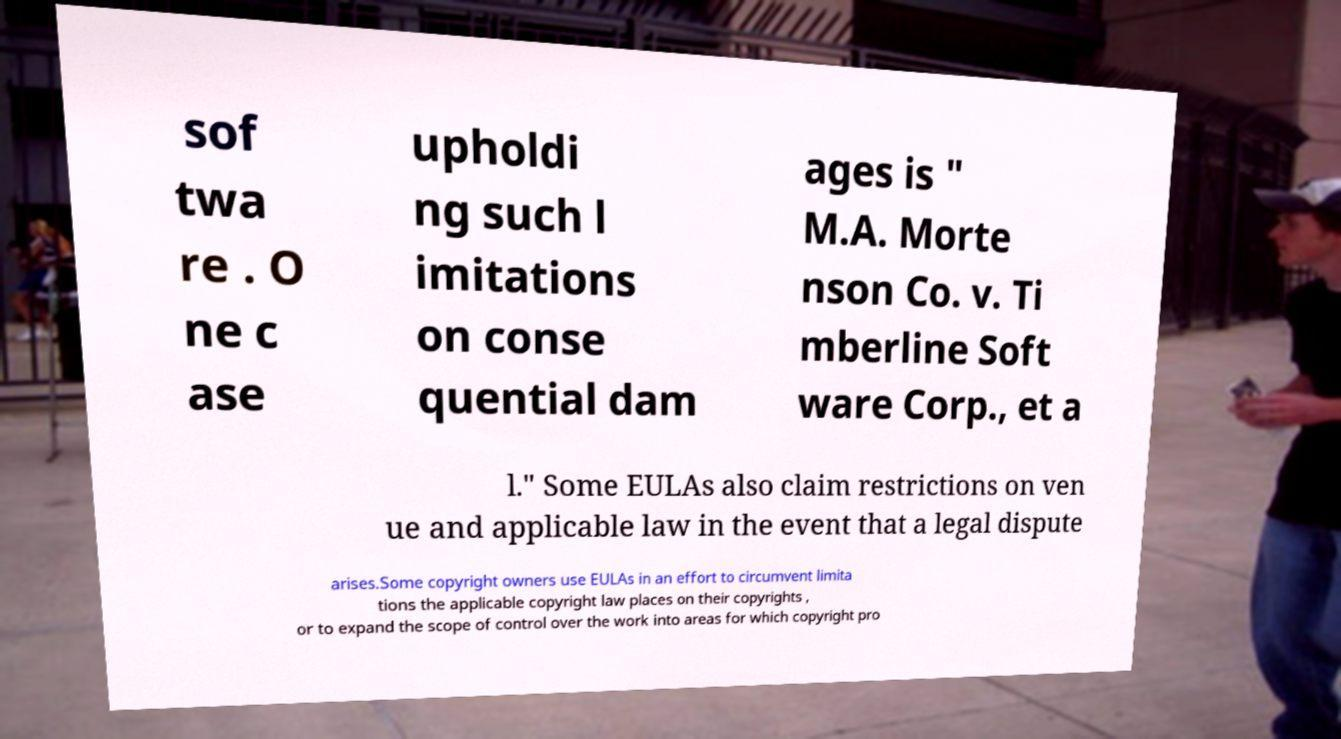Could you extract and type out the text from this image? sof twa re . O ne c ase upholdi ng such l imitations on conse quential dam ages is " M.A. Morte nson Co. v. Ti mberline Soft ware Corp., et a l." Some EULAs also claim restrictions on ven ue and applicable law in the event that a legal dispute arises.Some copyright owners use EULAs in an effort to circumvent limita tions the applicable copyright law places on their copyrights , or to expand the scope of control over the work into areas for which copyright pro 